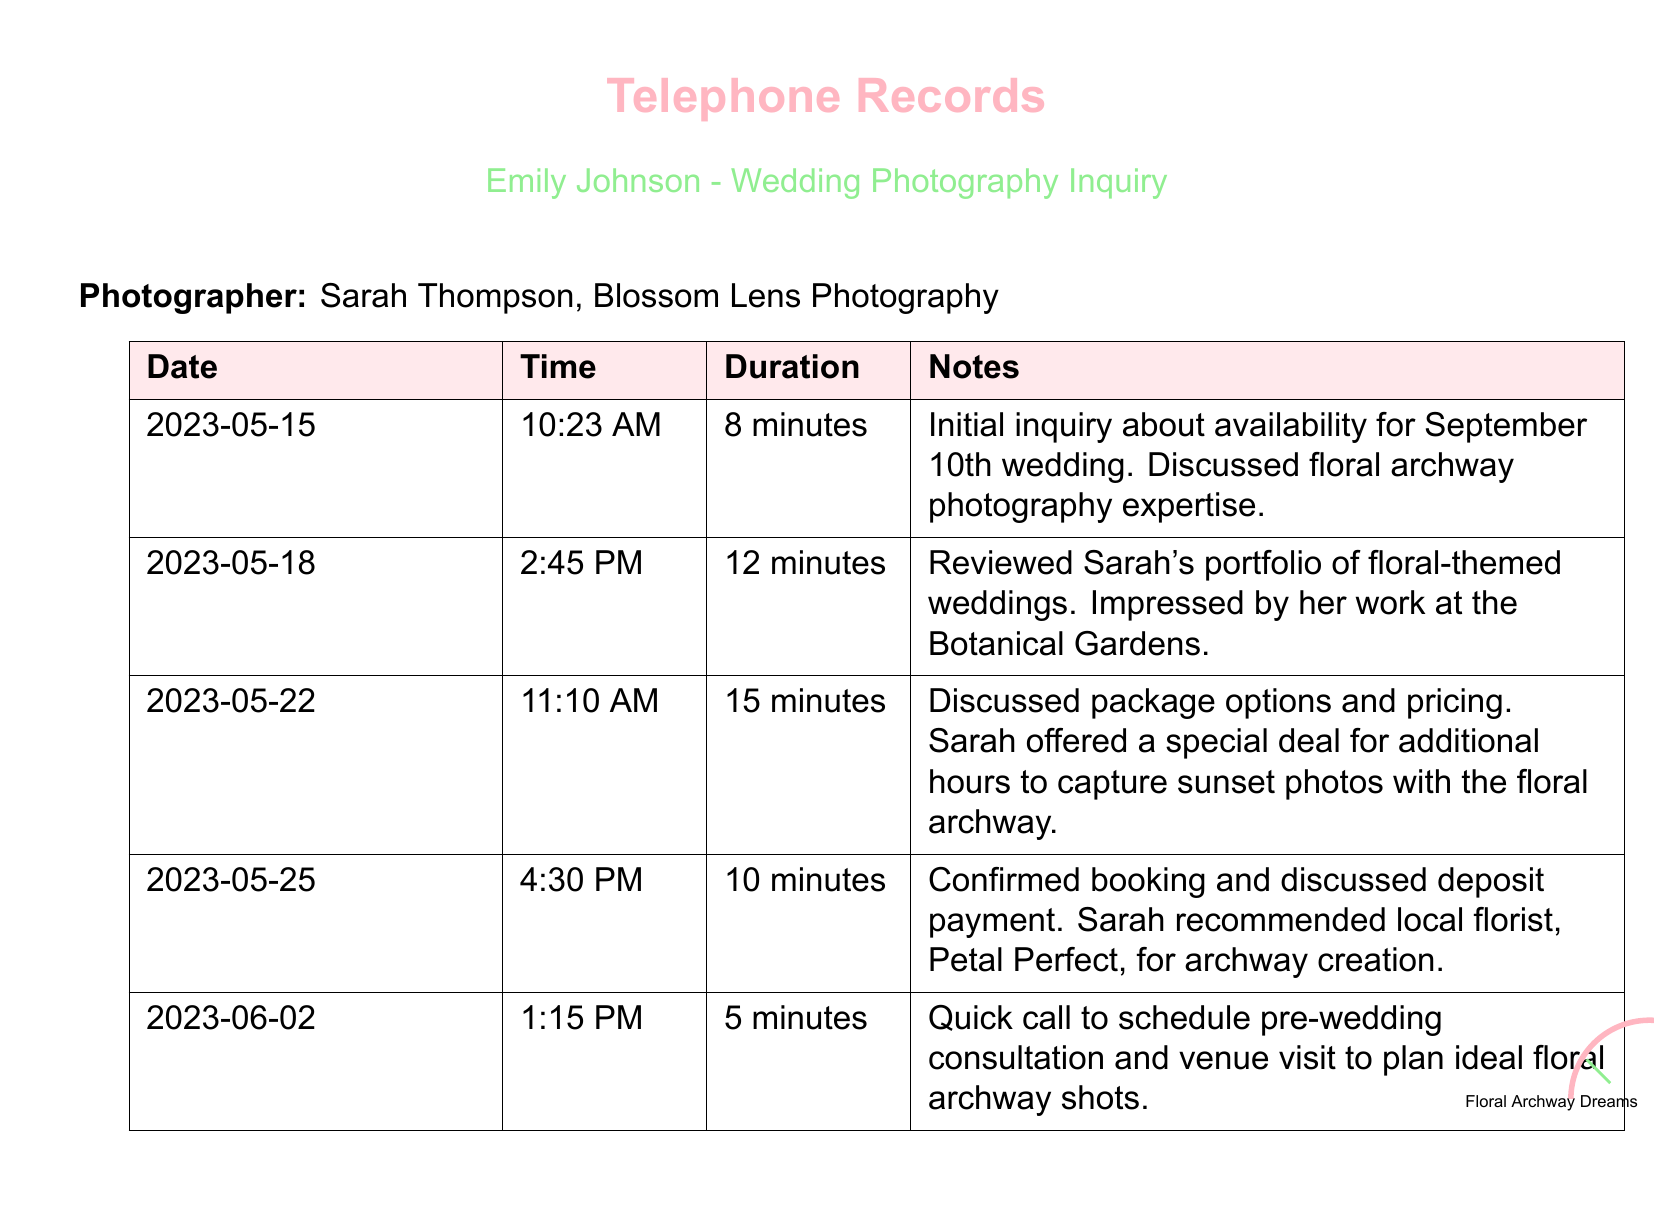What is the name of the photographer? The document states the photographer's name as Sarah Thompson.
Answer: Sarah Thompson What is the duration of the call on May 18th? The call on May 18th lasted for 12 minutes, as indicated in the document.
Answer: 12 minutes What date is the wedding? The wedding date discussed in the document is September 10th.
Answer: September 10th What special offer did Sarah provide? Sarah offered a special deal for additional hours for capturing sunset photos with the floral archway.
Answer: Additional hours for sunset photos Which florist did Sarah recommend? The local florist recommended by Sarah is Petal Perfect, as noted in the call on May 25th.
Answer: Petal Perfect How many total calls were made? The document lists a total of five calls made to the photographer.
Answer: Five calls What was the purpose of the call on June 2nd? The call on June 2nd was to schedule a pre-wedding consultation and venue visit.
Answer: Pre-wedding consultation What time did the initial inquiry call take place? The initial inquiry call occurred at 10:23 AM on May 15th.
Answer: 10:23 AM 